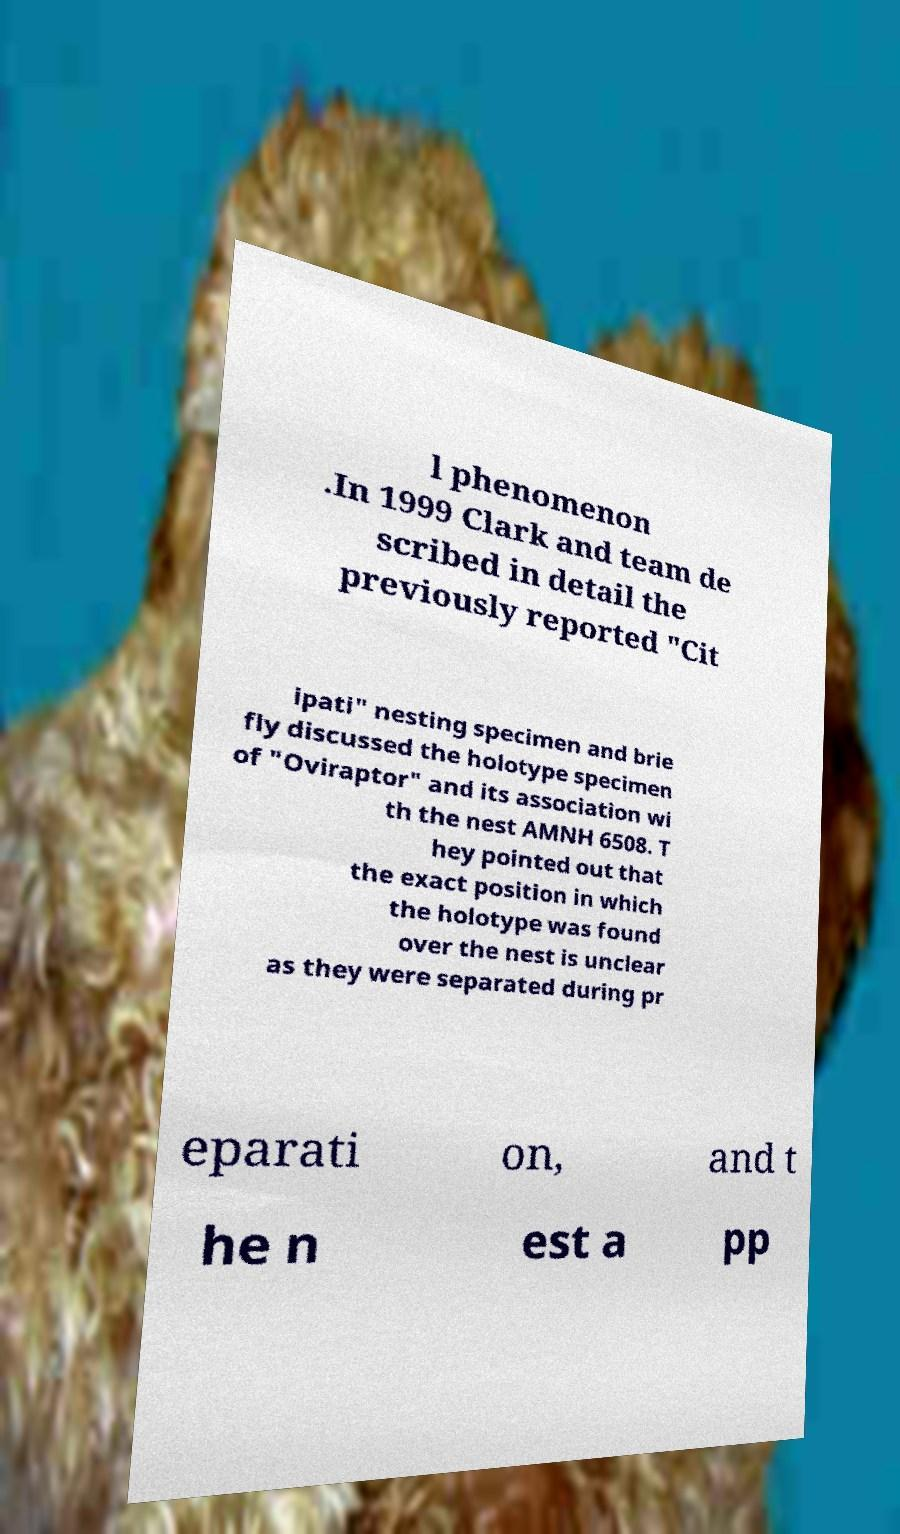Could you assist in decoding the text presented in this image and type it out clearly? l phenomenon .In 1999 Clark and team de scribed in detail the previously reported "Cit ipati" nesting specimen and brie fly discussed the holotype specimen of "Oviraptor" and its association wi th the nest AMNH 6508. T hey pointed out that the exact position in which the holotype was found over the nest is unclear as they were separated during pr eparati on, and t he n est a pp 